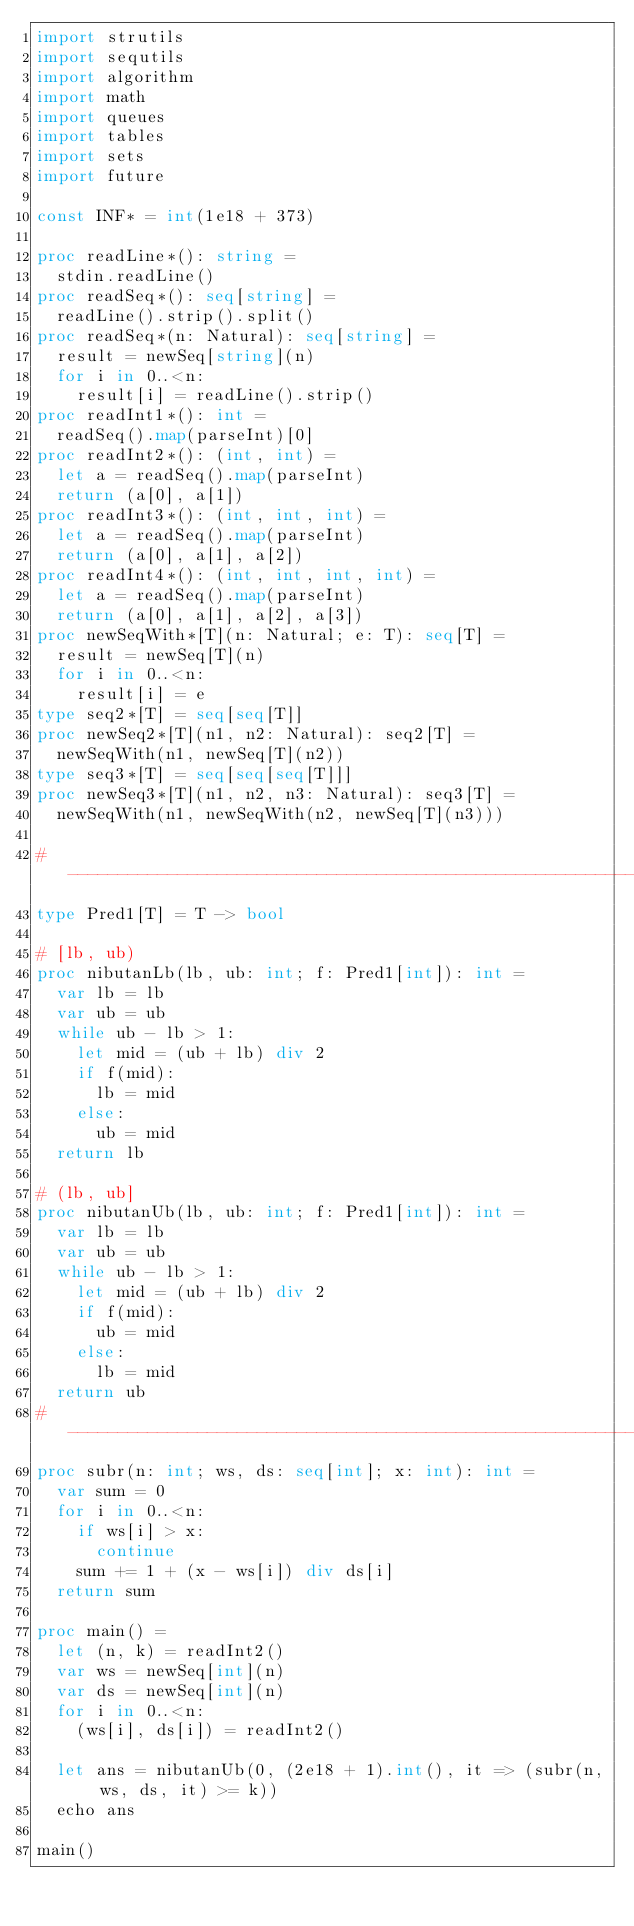<code> <loc_0><loc_0><loc_500><loc_500><_Nim_>import strutils
import sequtils
import algorithm
import math
import queues
import tables
import sets
import future

const INF* = int(1e18 + 373)

proc readLine*(): string =
  stdin.readLine()
proc readSeq*(): seq[string] =
  readLine().strip().split()
proc readSeq*(n: Natural): seq[string] =
  result = newSeq[string](n)
  for i in 0..<n:
    result[i] = readLine().strip()
proc readInt1*(): int =
  readSeq().map(parseInt)[0]
proc readInt2*(): (int, int) =
  let a = readSeq().map(parseInt)
  return (a[0], a[1])
proc readInt3*(): (int, int, int) =
  let a = readSeq().map(parseInt)
  return (a[0], a[1], a[2])
proc readInt4*(): (int, int, int, int) =
  let a = readSeq().map(parseInt)
  return (a[0], a[1], a[2], a[3])
proc newSeqWith*[T](n: Natural; e: T): seq[T] =
  result = newSeq[T](n)
  for i in 0..<n:
    result[i] = e
type seq2*[T] = seq[seq[T]]
proc newSeq2*[T](n1, n2: Natural): seq2[T] =
  newSeqWith(n1, newSeq[T](n2))
type seq3*[T] = seq[seq[seq[T]]]
proc newSeq3*[T](n1, n2, n3: Natural): seq3[T] =
  newSeqWith(n1, newSeqWith(n2, newSeq[T](n3)))

#------------------------------------------------------------------------------#
type Pred1[T] = T -> bool

# [lb, ub)
proc nibutanLb(lb, ub: int; f: Pred1[int]): int =
  var lb = lb
  var ub = ub
  while ub - lb > 1:
    let mid = (ub + lb) div 2
    if f(mid):
      lb = mid
    else:
      ub = mid
  return lb

# (lb, ub]
proc nibutanUb(lb, ub: int; f: Pred1[int]): int =
  var lb = lb
  var ub = ub
  while ub - lb > 1:
    let mid = (ub + lb) div 2
    if f(mid):
      ub = mid
    else:
      lb = mid
  return ub
#------------------------------------------------------------------------------#
proc subr(n: int; ws, ds: seq[int]; x: int): int =
  var sum = 0
  for i in 0..<n:
    if ws[i] > x:
      continue
    sum += 1 + (x - ws[i]) div ds[i]
  return sum

proc main() =
  let (n, k) = readInt2()
  var ws = newSeq[int](n)
  var ds = newSeq[int](n)
  for i in 0..<n:
    (ws[i], ds[i]) = readInt2()

  let ans = nibutanUb(0, (2e18 + 1).int(), it => (subr(n, ws, ds, it) >= k))
  echo ans

main()

</code> 